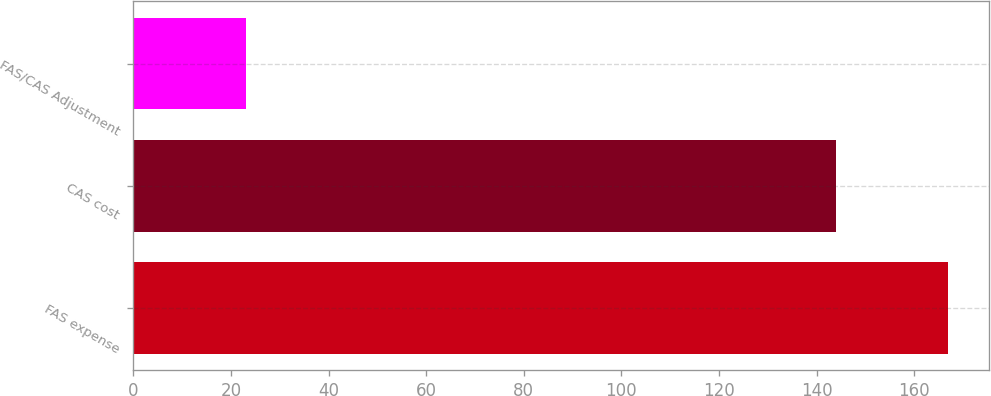Convert chart to OTSL. <chart><loc_0><loc_0><loc_500><loc_500><bar_chart><fcel>FAS expense<fcel>CAS cost<fcel>FAS/CAS Adjustment<nl><fcel>167<fcel>144<fcel>23<nl></chart> 